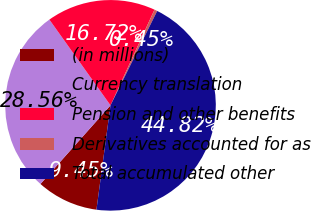Convert chart. <chart><loc_0><loc_0><loc_500><loc_500><pie_chart><fcel>(in millions)<fcel>Currency translation<fcel>Pension and other benefits<fcel>Derivatives accounted for as<fcel>Total accumulated other<nl><fcel>9.45%<fcel>28.56%<fcel>16.72%<fcel>0.45%<fcel>44.82%<nl></chart> 